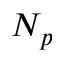<formula> <loc_0><loc_0><loc_500><loc_500>N _ { p }</formula> 